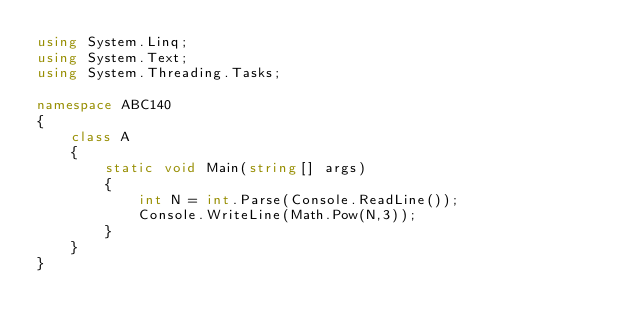Convert code to text. <code><loc_0><loc_0><loc_500><loc_500><_C#_>using System.Linq;
using System.Text;
using System.Threading.Tasks;

namespace ABC140
{
    class A
    {
        static void Main(string[] args)
        {
            int N = int.Parse(Console.ReadLine());
            Console.WriteLine(Math.Pow(N,3));
        }
    }
}
</code> 